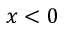Convert formula to latex. <formula><loc_0><loc_0><loc_500><loc_500>x < 0</formula> 